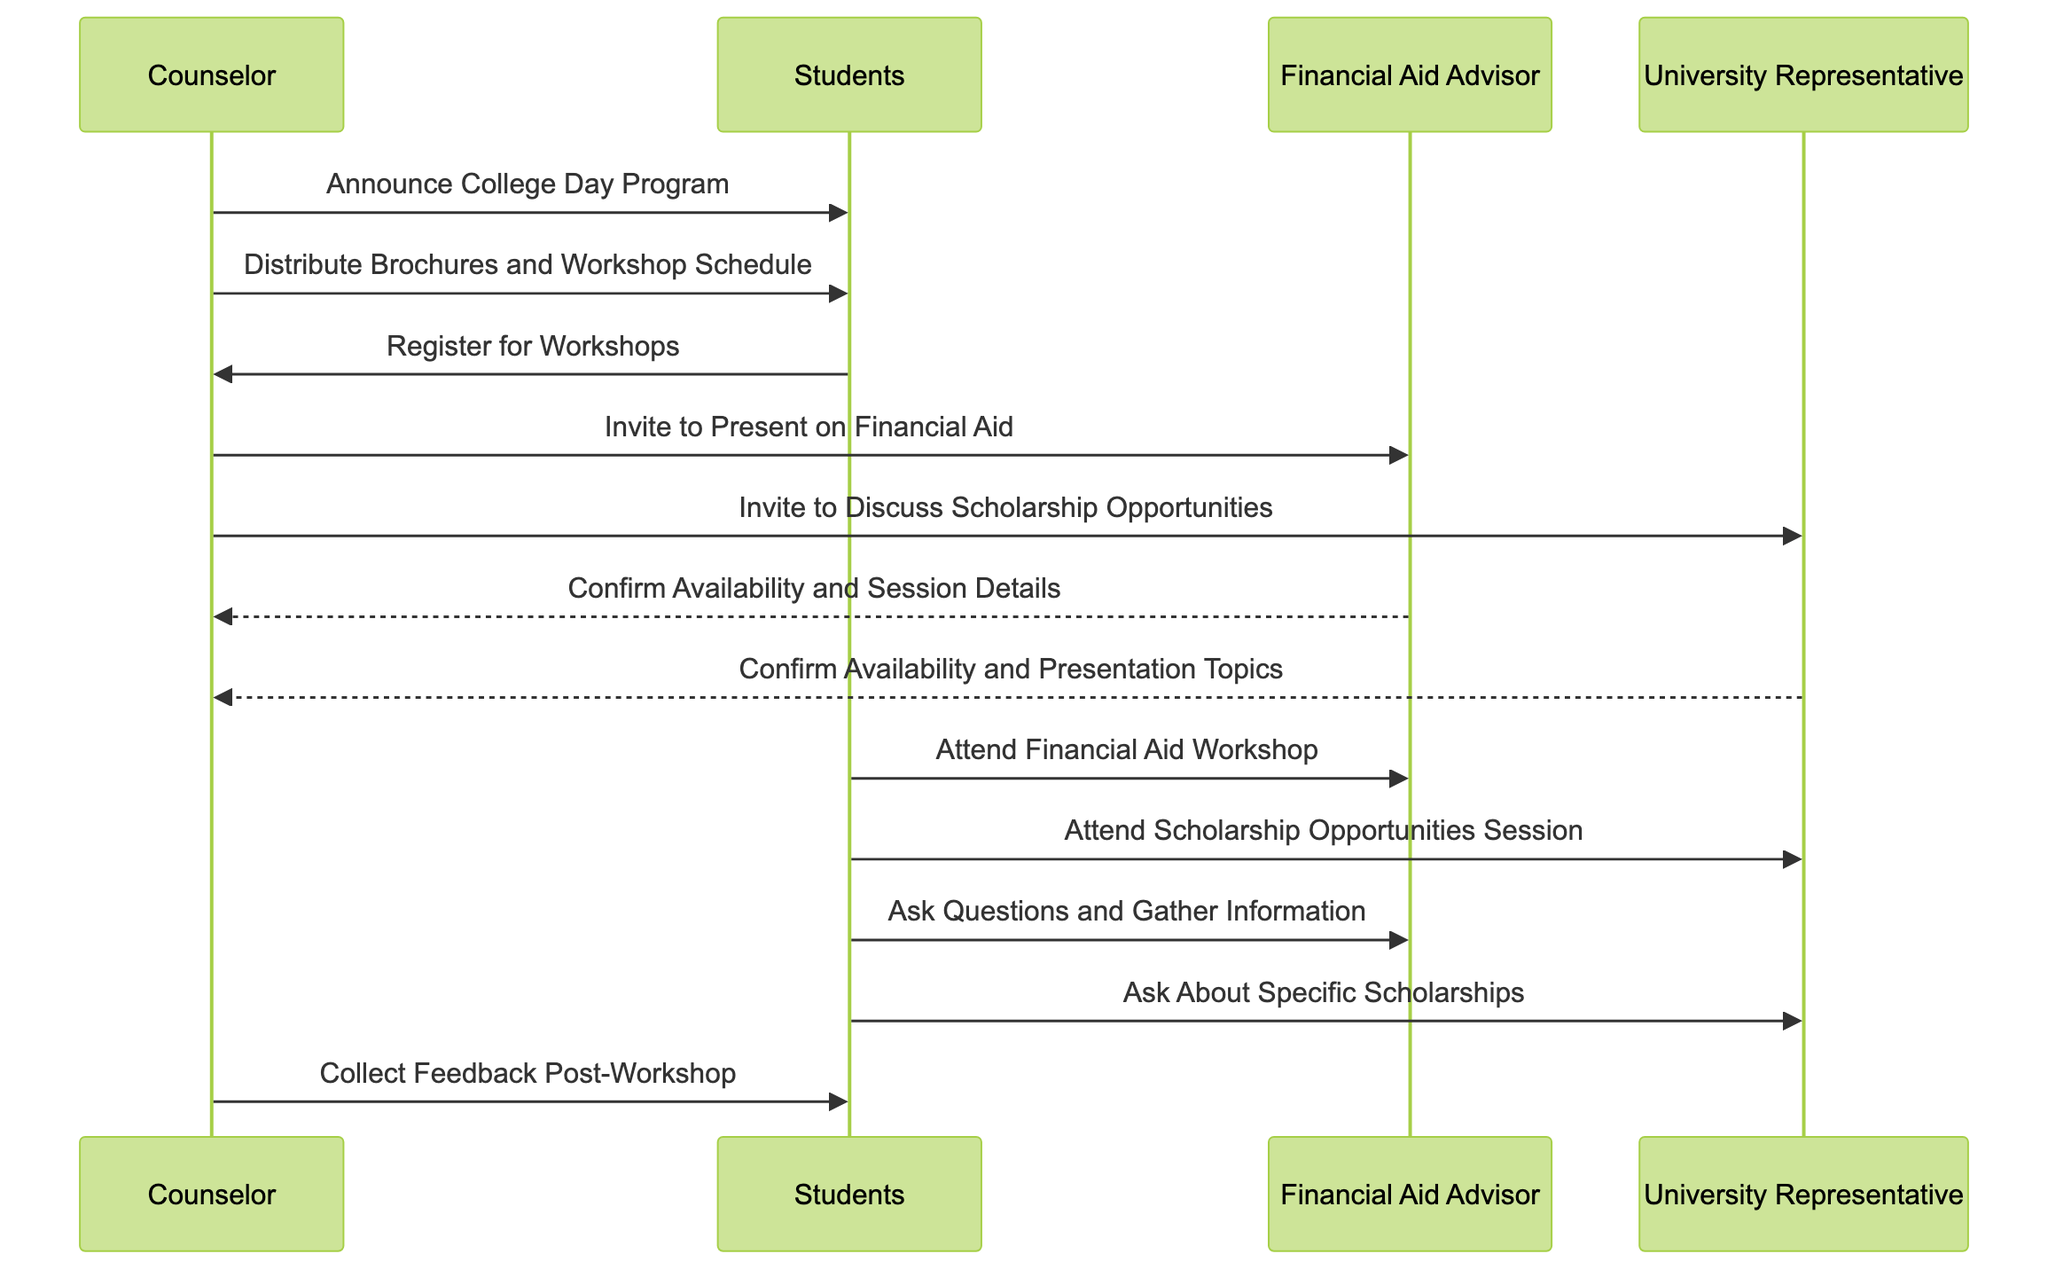What is the first action taken by the Counselor? The first action indicated in the diagram is an announcement made by the Counselor to the Students about the College Day Program. This is shown as the initial message in the sequence.
Answer: Announce College Day Program How many main participants are in the diagram? The diagram includes four main participants: Counselor, Students, Financial Aid Advisor, and University Representative. Counting each one gives the total number of participants.
Answer: Four What does the Counselor do after distributing the workshop schedule? After distributing the workshop schedule to the Students, the Counselor invites the Financial Aid Advisor to present on financial aid. This action follows immediately in the sequence of interactions.
Answer: Invite to Present on Financial Aid Which entity confirms availability for the session details? The Financial Aid Advisor confirms availability and session details to the Counselor based on the sequence of messages flowing in the diagram. This action is specifically directed to the Counselor.
Answer: Financial Aid Advisor What is the final action taken before collecting feedback? Before collecting feedback from the Students, the Counselor has completed the initial set of actions which includes confirming with the Financial Aid Advisor and University Representative as well as the workshops being attended by the Students. The last action directly preceding the feedback collection is the attendance of workshops.
Answer: Attend Scholarship Opportunities Session Who attends the Financial Aid Workshop? The Students attend the Financial Aid Workshop, which is indicated by a directed message from the Students to the Financial Aid Advisor in the sequence. This is a direct participant interaction in the sequence of the event.
Answer: Students What do Students do after attending the workshop sessions? After attending the workshop sessions, the Students ask questions and gather information, particularly from both the Financial Aid Advisor and University Representative, as shown by the directed messages from Students.
Answer: Ask Questions and Gather Information How many invitations does the Counselor send out? The Counselor sends out two invitations in the sequence: one to the Financial Aid Advisor for a financial aid presentation and one to the University Representative for discussing scholarship opportunities. This is reflected by two distinct messages directed from the Counselor.
Answer: Two 